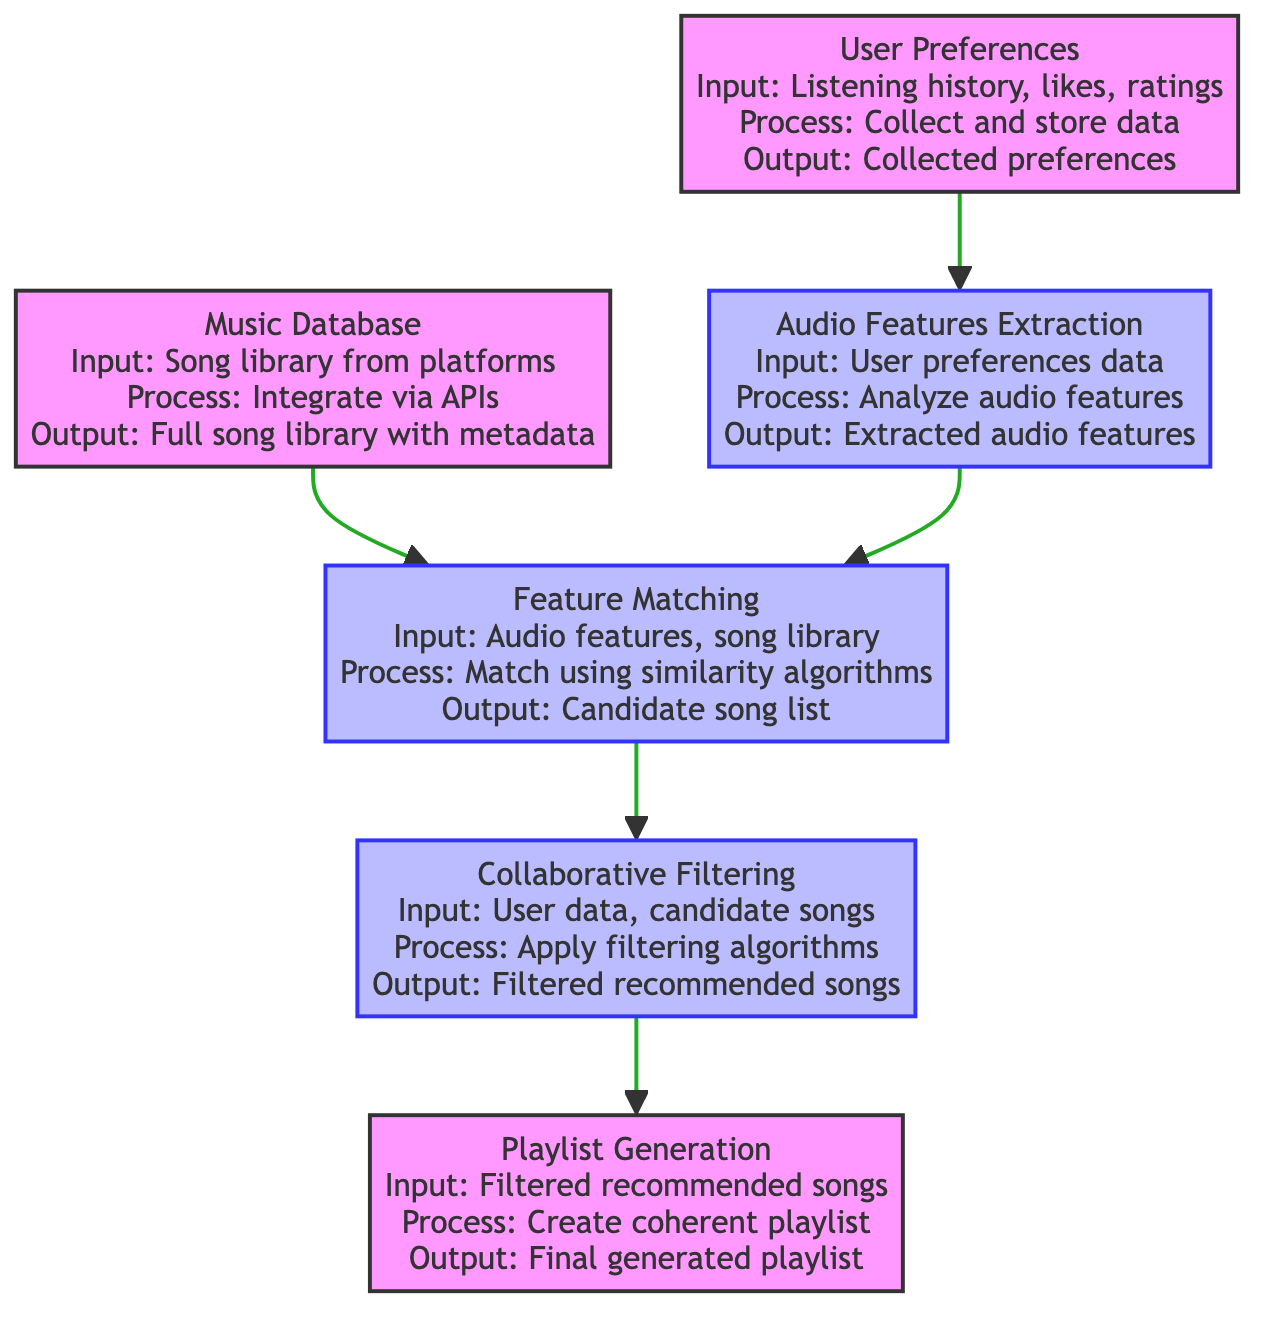What is the input for the User Preferences step? The input for the User Preferences step is the user's listening history, liked songs, and ratings. This is explicitly stated in the diagram under the User Preferences section.
Answer: User's listening history, liked songs, and ratings How many outputs are there in the flowchart? The flowchart has six distinct outputs, one for each step of the process: Collected user preferences data, Extracted audio features, Full song library including metadata and audio features, List of candidate songs, Filtered list of recommended songs, and Final generated playlist.
Answer: Six Which process follows Audio Features Extraction? The process that follows Audio Features Extraction is Feature Matching. This can be determined by following the arrows from the Audio Features Extraction node upwards in the flowchart.
Answer: Feature Matching What is the final output of the flow? The final output of the flow is the final generated playlist. This is listed at the end of the flowchart, which represents the end of the process leading to the final outcome.
Answer: Final generated playlist What is the input for Collaborative Filtering? The input for Collaborative Filtering includes user preferences data and a list of candidate songs. This information can be gathered from the nodes connected to the Collaborative Filtering node in the diagram.
Answer: User preferences data, list of candidate songs What process generates the candidate song list? The process that generates the candidate song list is Feature Matching. This is derived from the flow from the Audio Features Extraction node to the Feature Matching node.
Answer: Feature Matching How does audio features extraction relate to user preferences? Audio Features Extraction relies on user preferences data as input, indicating that it analyzes audio features of the songs that a user has liked according to their preferences. This shows a direct input-output relationship between these two processes.
Answer: It analyzes audio features of liked songs What is the role of Music Database in this flowchart? The role of Music Database is to provide a full song library including metadata and audio features. It serves as a crucial step in integrating external songs to match with user preferences later in the process.
Answer: To provide a full song library including metadata and audio features 